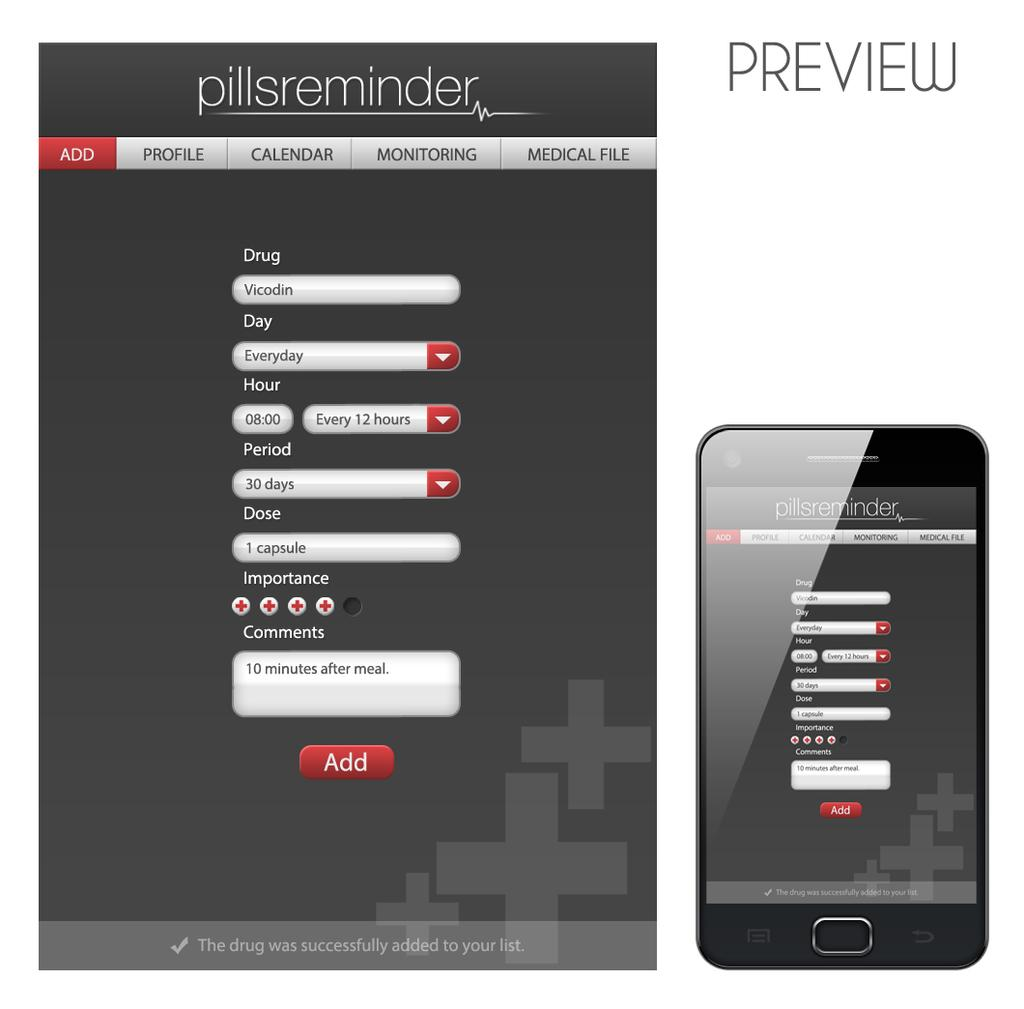<image>
Describe the image concisely. a page that is titled 'preview' and 'pillsreminder' 